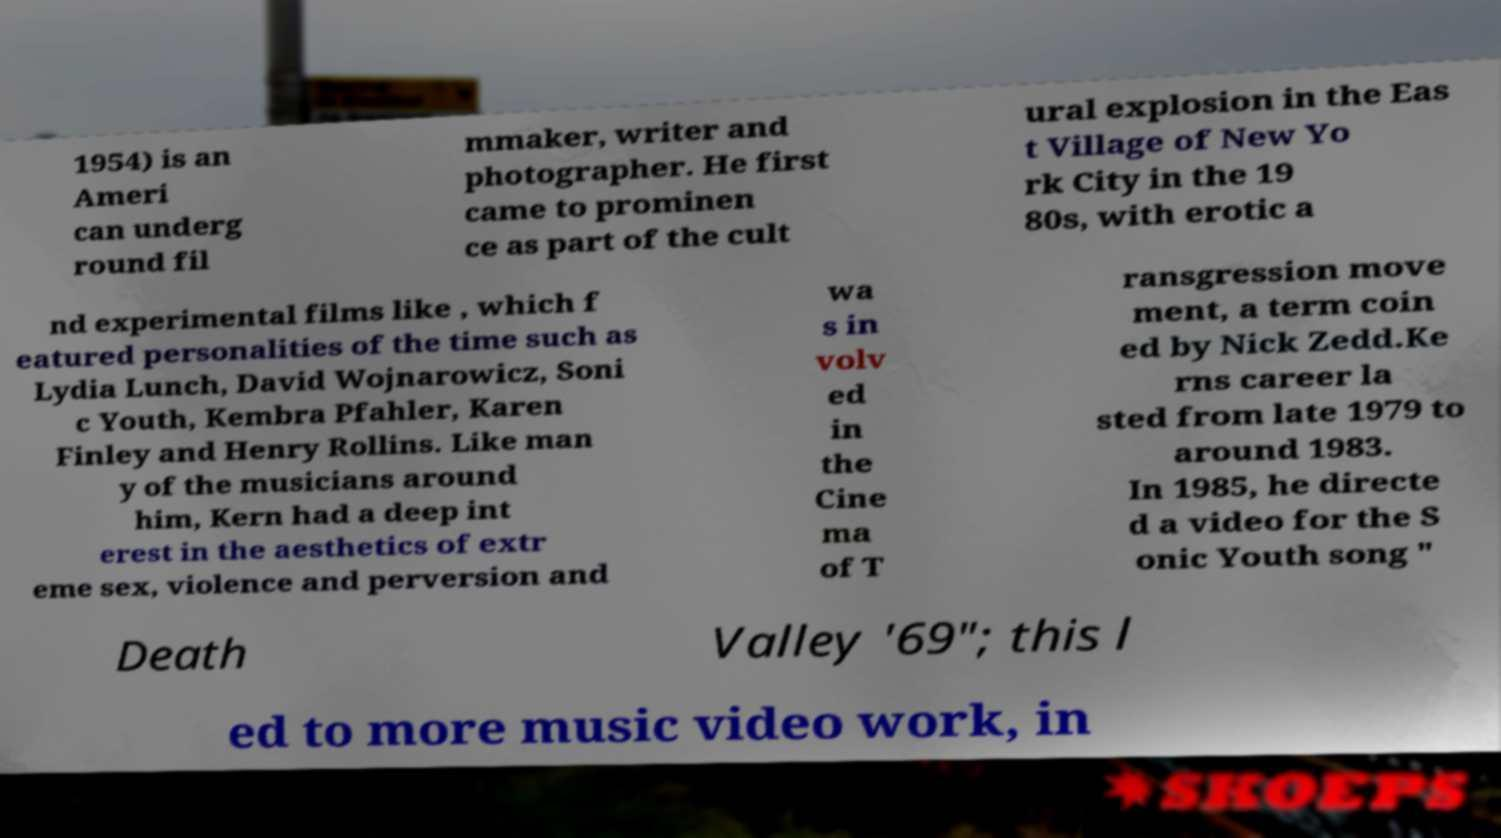Could you assist in decoding the text presented in this image and type it out clearly? 1954) is an Ameri can underg round fil mmaker, writer and photographer. He first came to prominen ce as part of the cult ural explosion in the Eas t Village of New Yo rk City in the 19 80s, with erotic a nd experimental films like , which f eatured personalities of the time such as Lydia Lunch, David Wojnarowicz, Soni c Youth, Kembra Pfahler, Karen Finley and Henry Rollins. Like man y of the musicians around him, Kern had a deep int erest in the aesthetics of extr eme sex, violence and perversion and wa s in volv ed in the Cine ma of T ransgression move ment, a term coin ed by Nick Zedd.Ke rns career la sted from late 1979 to around 1983. In 1985, he directe d a video for the S onic Youth song " Death Valley '69"; this l ed to more music video work, in 